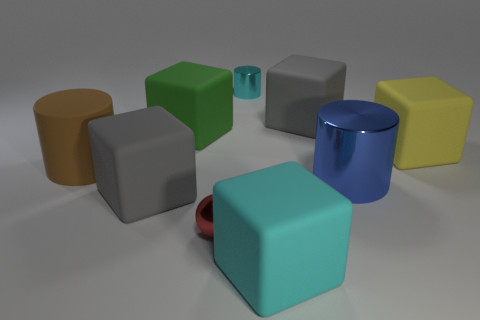Are there more cyan shiny cylinders than metal cylinders?
Provide a short and direct response. No. What material is the yellow block?
Give a very brief answer. Rubber. What number of objects are to the left of the small metal object left of the cyan metal cylinder?
Keep it short and to the point. 3. Do the small metal sphere and the cylinder behind the large brown matte object have the same color?
Keep it short and to the point. No. There is a metal cylinder that is the same size as the green thing; what is its color?
Ensure brevity in your answer.  Blue. Is there a green metal thing of the same shape as the brown matte object?
Your answer should be compact. No. Are there fewer tiny metal balls than blocks?
Offer a very short reply. Yes. What color is the large cylinder that is on the left side of the red object?
Provide a succinct answer. Brown. What is the shape of the matte thing in front of the tiny object that is in front of the rubber cylinder?
Provide a succinct answer. Cube. Is the material of the small cyan cylinder the same as the gray thing on the left side of the red shiny sphere?
Your response must be concise. No. 